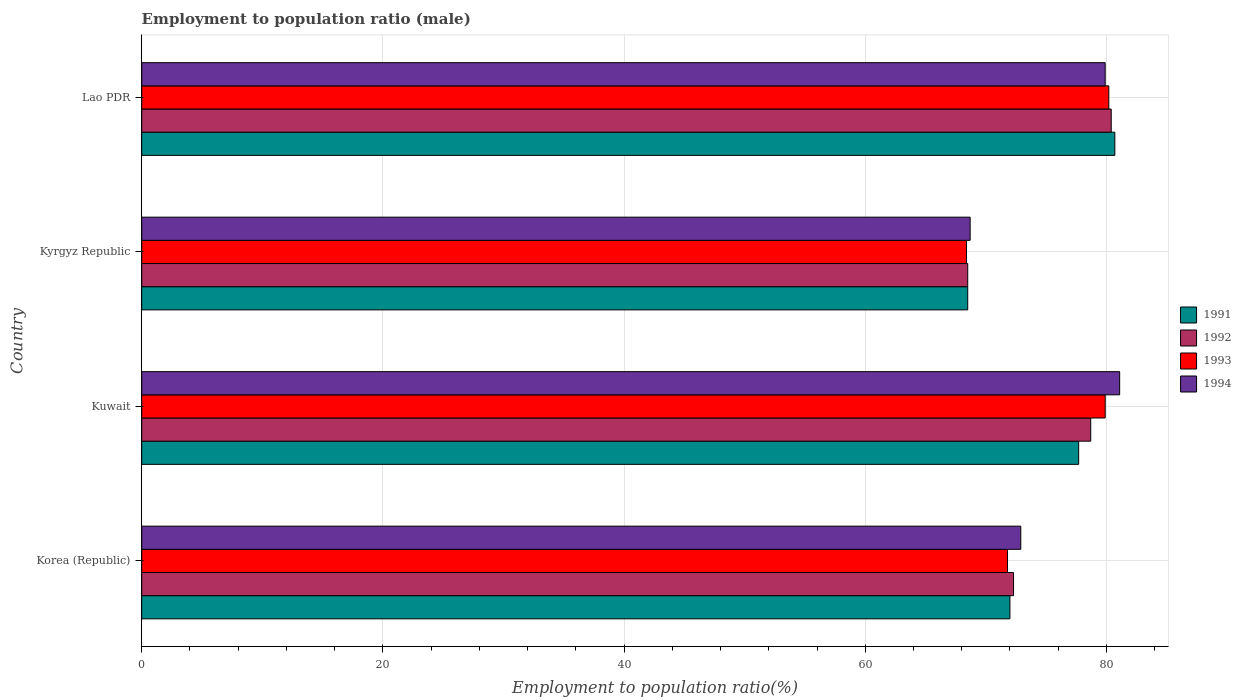How many different coloured bars are there?
Make the answer very short. 4. How many bars are there on the 3rd tick from the top?
Make the answer very short. 4. How many bars are there on the 3rd tick from the bottom?
Make the answer very short. 4. What is the label of the 2nd group of bars from the top?
Your answer should be very brief. Kyrgyz Republic. What is the employment to population ratio in 1991 in Kuwait?
Ensure brevity in your answer.  77.7. Across all countries, what is the maximum employment to population ratio in 1993?
Offer a terse response. 80.2. Across all countries, what is the minimum employment to population ratio in 1992?
Make the answer very short. 68.5. In which country was the employment to population ratio in 1991 maximum?
Offer a terse response. Lao PDR. In which country was the employment to population ratio in 1992 minimum?
Your response must be concise. Kyrgyz Republic. What is the total employment to population ratio in 1992 in the graph?
Your response must be concise. 299.9. What is the difference between the employment to population ratio in 1993 in Korea (Republic) and that in Kyrgyz Republic?
Your response must be concise. 3.4. What is the difference between the employment to population ratio in 1993 in Kyrgyz Republic and the employment to population ratio in 1994 in Korea (Republic)?
Keep it short and to the point. -4.5. What is the average employment to population ratio in 1991 per country?
Keep it short and to the point. 74.72. What is the difference between the employment to population ratio in 1993 and employment to population ratio in 1992 in Lao PDR?
Ensure brevity in your answer.  -0.2. In how many countries, is the employment to population ratio in 1994 greater than 12 %?
Provide a short and direct response. 4. What is the ratio of the employment to population ratio in 1992 in Kyrgyz Republic to that in Lao PDR?
Make the answer very short. 0.85. Is the employment to population ratio in 1991 in Korea (Republic) less than that in Kyrgyz Republic?
Give a very brief answer. No. Is the difference between the employment to population ratio in 1993 in Korea (Republic) and Lao PDR greater than the difference between the employment to population ratio in 1992 in Korea (Republic) and Lao PDR?
Offer a terse response. No. What is the difference between the highest and the lowest employment to population ratio in 1994?
Keep it short and to the point. 12.4. In how many countries, is the employment to population ratio in 1993 greater than the average employment to population ratio in 1993 taken over all countries?
Offer a terse response. 2. What does the 3rd bar from the top in Korea (Republic) represents?
Your response must be concise. 1992. What does the 3rd bar from the bottom in Kuwait represents?
Keep it short and to the point. 1993. Is it the case that in every country, the sum of the employment to population ratio in 1991 and employment to population ratio in 1992 is greater than the employment to population ratio in 1994?
Provide a short and direct response. Yes. How many bars are there?
Keep it short and to the point. 16. Are all the bars in the graph horizontal?
Provide a short and direct response. Yes. What is the difference between two consecutive major ticks on the X-axis?
Provide a short and direct response. 20. Are the values on the major ticks of X-axis written in scientific E-notation?
Provide a succinct answer. No. Does the graph contain grids?
Keep it short and to the point. Yes. How are the legend labels stacked?
Offer a terse response. Vertical. What is the title of the graph?
Your answer should be very brief. Employment to population ratio (male). Does "2005" appear as one of the legend labels in the graph?
Give a very brief answer. No. What is the Employment to population ratio(%) of 1992 in Korea (Republic)?
Provide a short and direct response. 72.3. What is the Employment to population ratio(%) in 1993 in Korea (Republic)?
Your answer should be compact. 71.8. What is the Employment to population ratio(%) in 1994 in Korea (Republic)?
Your response must be concise. 72.9. What is the Employment to population ratio(%) of 1991 in Kuwait?
Provide a short and direct response. 77.7. What is the Employment to population ratio(%) in 1992 in Kuwait?
Give a very brief answer. 78.7. What is the Employment to population ratio(%) of 1993 in Kuwait?
Your response must be concise. 79.9. What is the Employment to population ratio(%) in 1994 in Kuwait?
Provide a short and direct response. 81.1. What is the Employment to population ratio(%) of 1991 in Kyrgyz Republic?
Your response must be concise. 68.5. What is the Employment to population ratio(%) of 1992 in Kyrgyz Republic?
Offer a very short reply. 68.5. What is the Employment to population ratio(%) of 1993 in Kyrgyz Republic?
Your answer should be very brief. 68.4. What is the Employment to population ratio(%) of 1994 in Kyrgyz Republic?
Ensure brevity in your answer.  68.7. What is the Employment to population ratio(%) of 1991 in Lao PDR?
Keep it short and to the point. 80.7. What is the Employment to population ratio(%) of 1992 in Lao PDR?
Make the answer very short. 80.4. What is the Employment to population ratio(%) of 1993 in Lao PDR?
Keep it short and to the point. 80.2. What is the Employment to population ratio(%) in 1994 in Lao PDR?
Your answer should be compact. 79.9. Across all countries, what is the maximum Employment to population ratio(%) of 1991?
Provide a short and direct response. 80.7. Across all countries, what is the maximum Employment to population ratio(%) in 1992?
Keep it short and to the point. 80.4. Across all countries, what is the maximum Employment to population ratio(%) in 1993?
Offer a terse response. 80.2. Across all countries, what is the maximum Employment to population ratio(%) in 1994?
Offer a very short reply. 81.1. Across all countries, what is the minimum Employment to population ratio(%) in 1991?
Ensure brevity in your answer.  68.5. Across all countries, what is the minimum Employment to population ratio(%) in 1992?
Ensure brevity in your answer.  68.5. Across all countries, what is the minimum Employment to population ratio(%) of 1993?
Your answer should be compact. 68.4. Across all countries, what is the minimum Employment to population ratio(%) in 1994?
Provide a succinct answer. 68.7. What is the total Employment to population ratio(%) in 1991 in the graph?
Offer a very short reply. 298.9. What is the total Employment to population ratio(%) of 1992 in the graph?
Ensure brevity in your answer.  299.9. What is the total Employment to population ratio(%) in 1993 in the graph?
Make the answer very short. 300.3. What is the total Employment to population ratio(%) of 1994 in the graph?
Make the answer very short. 302.6. What is the difference between the Employment to population ratio(%) in 1993 in Korea (Republic) and that in Kuwait?
Offer a very short reply. -8.1. What is the difference between the Employment to population ratio(%) in 1994 in Korea (Republic) and that in Kyrgyz Republic?
Your response must be concise. 4.2. What is the difference between the Employment to population ratio(%) of 1993 in Korea (Republic) and that in Lao PDR?
Provide a short and direct response. -8.4. What is the difference between the Employment to population ratio(%) in 1993 in Kuwait and that in Kyrgyz Republic?
Your answer should be compact. 11.5. What is the difference between the Employment to population ratio(%) in 1994 in Kuwait and that in Kyrgyz Republic?
Give a very brief answer. 12.4. What is the difference between the Employment to population ratio(%) in 1993 in Kuwait and that in Lao PDR?
Your answer should be compact. -0.3. What is the difference between the Employment to population ratio(%) in 1994 in Kuwait and that in Lao PDR?
Keep it short and to the point. 1.2. What is the difference between the Employment to population ratio(%) in 1991 in Kyrgyz Republic and that in Lao PDR?
Make the answer very short. -12.2. What is the difference between the Employment to population ratio(%) of 1992 in Kyrgyz Republic and that in Lao PDR?
Give a very brief answer. -11.9. What is the difference between the Employment to population ratio(%) in 1993 in Kyrgyz Republic and that in Lao PDR?
Keep it short and to the point. -11.8. What is the difference between the Employment to population ratio(%) of 1994 in Kyrgyz Republic and that in Lao PDR?
Provide a succinct answer. -11.2. What is the difference between the Employment to population ratio(%) of 1991 in Korea (Republic) and the Employment to population ratio(%) of 1992 in Kuwait?
Provide a short and direct response. -6.7. What is the difference between the Employment to population ratio(%) in 1991 in Korea (Republic) and the Employment to population ratio(%) in 1994 in Kuwait?
Ensure brevity in your answer.  -9.1. What is the difference between the Employment to population ratio(%) in 1992 in Korea (Republic) and the Employment to population ratio(%) in 1994 in Kuwait?
Ensure brevity in your answer.  -8.8. What is the difference between the Employment to population ratio(%) of 1993 in Korea (Republic) and the Employment to population ratio(%) of 1994 in Kuwait?
Keep it short and to the point. -9.3. What is the difference between the Employment to population ratio(%) in 1991 in Korea (Republic) and the Employment to population ratio(%) in 1993 in Kyrgyz Republic?
Offer a very short reply. 3.6. What is the difference between the Employment to population ratio(%) of 1991 in Korea (Republic) and the Employment to population ratio(%) of 1994 in Kyrgyz Republic?
Offer a terse response. 3.3. What is the difference between the Employment to population ratio(%) in 1992 in Korea (Republic) and the Employment to population ratio(%) in 1993 in Kyrgyz Republic?
Offer a terse response. 3.9. What is the difference between the Employment to population ratio(%) in 1992 in Korea (Republic) and the Employment to population ratio(%) in 1993 in Lao PDR?
Give a very brief answer. -7.9. What is the difference between the Employment to population ratio(%) of 1992 in Korea (Republic) and the Employment to population ratio(%) of 1994 in Lao PDR?
Ensure brevity in your answer.  -7.6. What is the difference between the Employment to population ratio(%) in 1991 in Kuwait and the Employment to population ratio(%) in 1994 in Kyrgyz Republic?
Give a very brief answer. 9. What is the difference between the Employment to population ratio(%) of 1992 in Kuwait and the Employment to population ratio(%) of 1993 in Kyrgyz Republic?
Offer a very short reply. 10.3. What is the difference between the Employment to population ratio(%) in 1991 in Kuwait and the Employment to population ratio(%) in 1993 in Lao PDR?
Your response must be concise. -2.5. What is the difference between the Employment to population ratio(%) of 1991 in Kuwait and the Employment to population ratio(%) of 1994 in Lao PDR?
Ensure brevity in your answer.  -2.2. What is the difference between the Employment to population ratio(%) in 1992 in Kuwait and the Employment to population ratio(%) in 1993 in Lao PDR?
Your answer should be very brief. -1.5. What is the difference between the Employment to population ratio(%) in 1993 in Kuwait and the Employment to population ratio(%) in 1994 in Lao PDR?
Give a very brief answer. 0. What is the difference between the Employment to population ratio(%) of 1991 in Kyrgyz Republic and the Employment to population ratio(%) of 1992 in Lao PDR?
Your answer should be very brief. -11.9. What is the difference between the Employment to population ratio(%) in 1991 in Kyrgyz Republic and the Employment to population ratio(%) in 1994 in Lao PDR?
Give a very brief answer. -11.4. What is the difference between the Employment to population ratio(%) of 1992 in Kyrgyz Republic and the Employment to population ratio(%) of 1993 in Lao PDR?
Provide a short and direct response. -11.7. What is the difference between the Employment to population ratio(%) of 1993 in Kyrgyz Republic and the Employment to population ratio(%) of 1994 in Lao PDR?
Provide a short and direct response. -11.5. What is the average Employment to population ratio(%) of 1991 per country?
Your answer should be compact. 74.72. What is the average Employment to population ratio(%) in 1992 per country?
Make the answer very short. 74.97. What is the average Employment to population ratio(%) of 1993 per country?
Provide a short and direct response. 75.08. What is the average Employment to population ratio(%) of 1994 per country?
Offer a terse response. 75.65. What is the difference between the Employment to population ratio(%) in 1991 and Employment to population ratio(%) in 1994 in Korea (Republic)?
Offer a very short reply. -0.9. What is the difference between the Employment to population ratio(%) of 1991 and Employment to population ratio(%) of 1993 in Kuwait?
Your answer should be compact. -2.2. What is the difference between the Employment to population ratio(%) of 1992 and Employment to population ratio(%) of 1993 in Kuwait?
Provide a short and direct response. -1.2. What is the difference between the Employment to population ratio(%) in 1992 and Employment to population ratio(%) in 1994 in Kuwait?
Your answer should be compact. -2.4. What is the difference between the Employment to population ratio(%) of 1991 and Employment to population ratio(%) of 1992 in Kyrgyz Republic?
Give a very brief answer. 0. What is the difference between the Employment to population ratio(%) in 1991 and Employment to population ratio(%) in 1993 in Kyrgyz Republic?
Ensure brevity in your answer.  0.1. What is the difference between the Employment to population ratio(%) in 1991 and Employment to population ratio(%) in 1994 in Kyrgyz Republic?
Your answer should be compact. -0.2. What is the difference between the Employment to population ratio(%) of 1992 and Employment to population ratio(%) of 1993 in Kyrgyz Republic?
Your response must be concise. 0.1. What is the difference between the Employment to population ratio(%) of 1992 and Employment to population ratio(%) of 1994 in Kyrgyz Republic?
Offer a terse response. -0.2. What is the difference between the Employment to population ratio(%) of 1992 and Employment to population ratio(%) of 1993 in Lao PDR?
Offer a very short reply. 0.2. What is the difference between the Employment to population ratio(%) in 1993 and Employment to population ratio(%) in 1994 in Lao PDR?
Provide a short and direct response. 0.3. What is the ratio of the Employment to population ratio(%) in 1991 in Korea (Republic) to that in Kuwait?
Provide a succinct answer. 0.93. What is the ratio of the Employment to population ratio(%) of 1992 in Korea (Republic) to that in Kuwait?
Ensure brevity in your answer.  0.92. What is the ratio of the Employment to population ratio(%) in 1993 in Korea (Republic) to that in Kuwait?
Provide a succinct answer. 0.9. What is the ratio of the Employment to population ratio(%) in 1994 in Korea (Republic) to that in Kuwait?
Offer a very short reply. 0.9. What is the ratio of the Employment to population ratio(%) of 1991 in Korea (Republic) to that in Kyrgyz Republic?
Provide a succinct answer. 1.05. What is the ratio of the Employment to population ratio(%) in 1992 in Korea (Republic) to that in Kyrgyz Republic?
Keep it short and to the point. 1.06. What is the ratio of the Employment to population ratio(%) in 1993 in Korea (Republic) to that in Kyrgyz Republic?
Your answer should be very brief. 1.05. What is the ratio of the Employment to population ratio(%) in 1994 in Korea (Republic) to that in Kyrgyz Republic?
Make the answer very short. 1.06. What is the ratio of the Employment to population ratio(%) in 1991 in Korea (Republic) to that in Lao PDR?
Keep it short and to the point. 0.89. What is the ratio of the Employment to population ratio(%) in 1992 in Korea (Republic) to that in Lao PDR?
Your answer should be very brief. 0.9. What is the ratio of the Employment to population ratio(%) in 1993 in Korea (Republic) to that in Lao PDR?
Your answer should be very brief. 0.9. What is the ratio of the Employment to population ratio(%) of 1994 in Korea (Republic) to that in Lao PDR?
Your response must be concise. 0.91. What is the ratio of the Employment to population ratio(%) of 1991 in Kuwait to that in Kyrgyz Republic?
Make the answer very short. 1.13. What is the ratio of the Employment to population ratio(%) of 1992 in Kuwait to that in Kyrgyz Republic?
Make the answer very short. 1.15. What is the ratio of the Employment to population ratio(%) of 1993 in Kuwait to that in Kyrgyz Republic?
Give a very brief answer. 1.17. What is the ratio of the Employment to population ratio(%) in 1994 in Kuwait to that in Kyrgyz Republic?
Your answer should be very brief. 1.18. What is the ratio of the Employment to population ratio(%) of 1991 in Kuwait to that in Lao PDR?
Make the answer very short. 0.96. What is the ratio of the Employment to population ratio(%) in 1992 in Kuwait to that in Lao PDR?
Your response must be concise. 0.98. What is the ratio of the Employment to population ratio(%) in 1993 in Kuwait to that in Lao PDR?
Provide a short and direct response. 1. What is the ratio of the Employment to population ratio(%) of 1991 in Kyrgyz Republic to that in Lao PDR?
Provide a succinct answer. 0.85. What is the ratio of the Employment to population ratio(%) in 1992 in Kyrgyz Republic to that in Lao PDR?
Offer a very short reply. 0.85. What is the ratio of the Employment to population ratio(%) of 1993 in Kyrgyz Republic to that in Lao PDR?
Your answer should be compact. 0.85. What is the ratio of the Employment to population ratio(%) in 1994 in Kyrgyz Republic to that in Lao PDR?
Give a very brief answer. 0.86. What is the difference between the highest and the second highest Employment to population ratio(%) of 1992?
Your answer should be very brief. 1.7. What is the difference between the highest and the second highest Employment to population ratio(%) in 1993?
Provide a short and direct response. 0.3. What is the difference between the highest and the second highest Employment to population ratio(%) of 1994?
Give a very brief answer. 1.2. What is the difference between the highest and the lowest Employment to population ratio(%) of 1993?
Provide a succinct answer. 11.8. What is the difference between the highest and the lowest Employment to population ratio(%) in 1994?
Offer a very short reply. 12.4. 